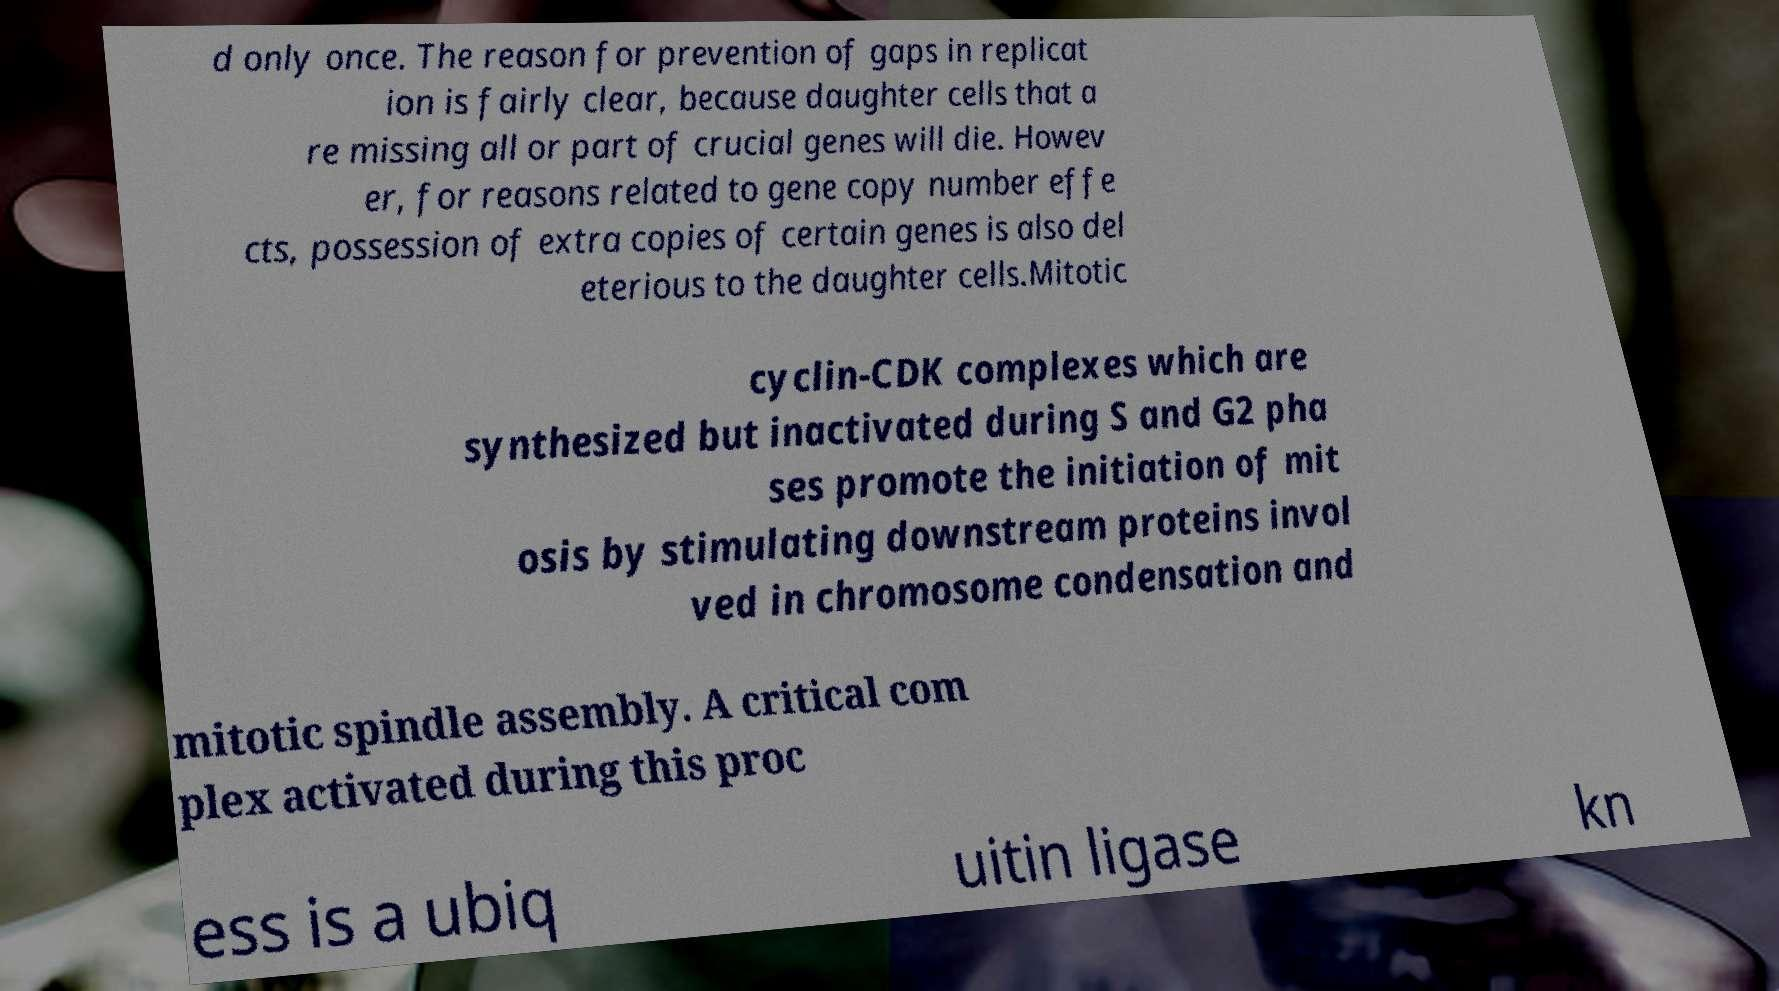For documentation purposes, I need the text within this image transcribed. Could you provide that? d only once. The reason for prevention of gaps in replicat ion is fairly clear, because daughter cells that a re missing all or part of crucial genes will die. Howev er, for reasons related to gene copy number effe cts, possession of extra copies of certain genes is also del eterious to the daughter cells.Mitotic cyclin-CDK complexes which are synthesized but inactivated during S and G2 pha ses promote the initiation of mit osis by stimulating downstream proteins invol ved in chromosome condensation and mitotic spindle assembly. A critical com plex activated during this proc ess is a ubiq uitin ligase kn 